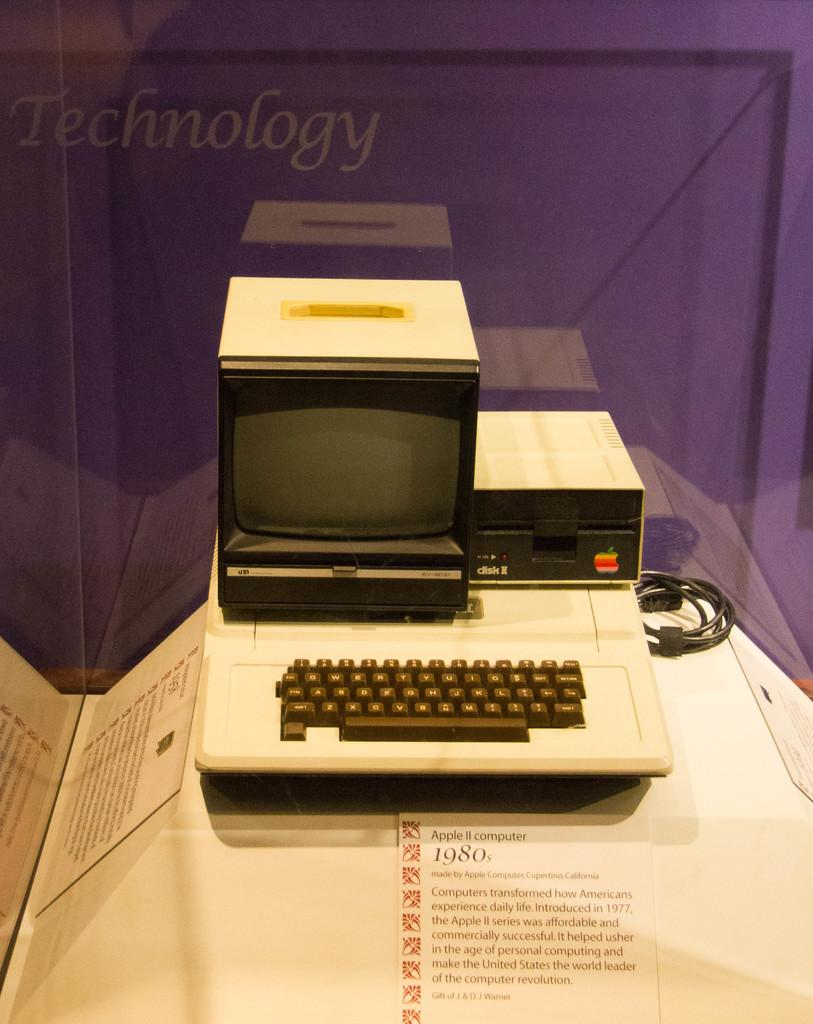<image>
Render a clear and concise summary of the photo. an old Apple II computer from the 1980s on display at a museum 